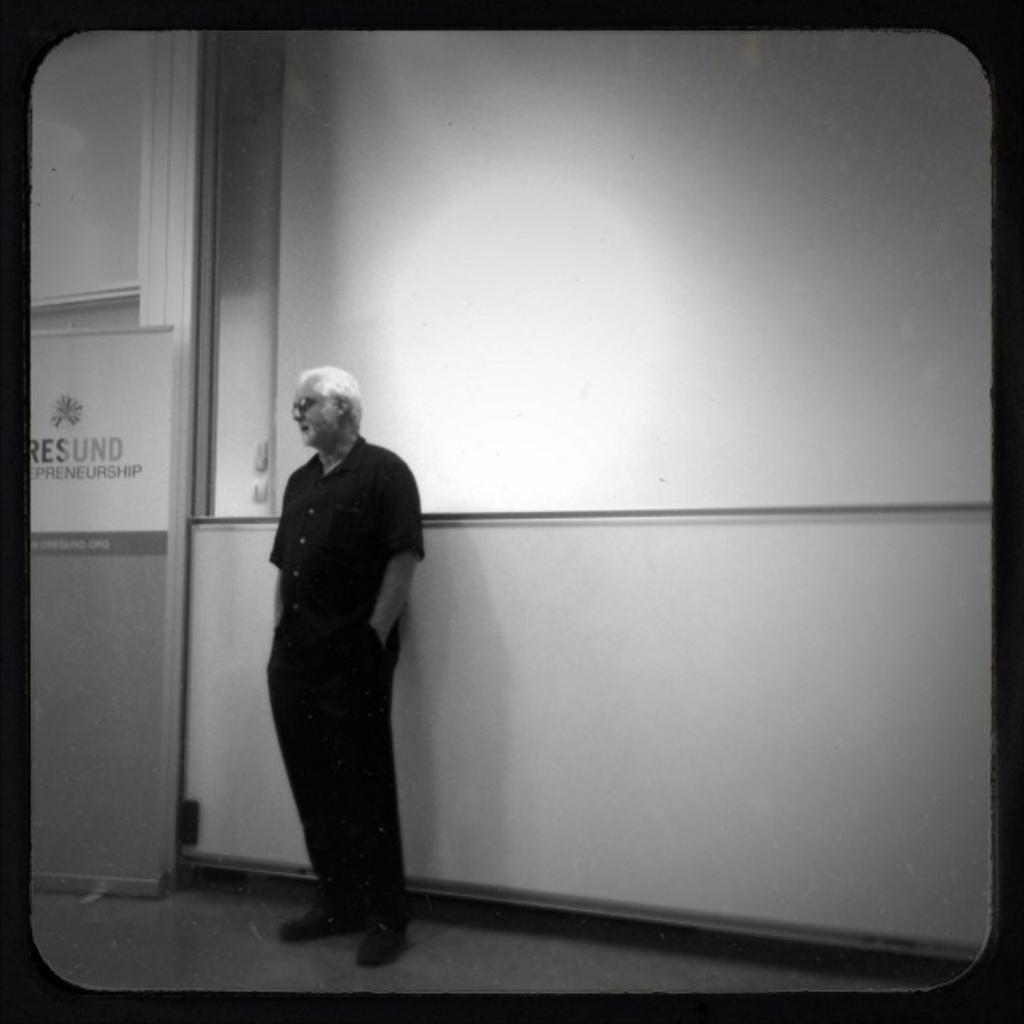How would you summarize this image in a sentence or two? In this image I can see the person is standing. I can see the board, glass wall and the image is in black and white. 